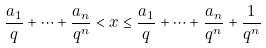<formula> <loc_0><loc_0><loc_500><loc_500>\frac { a _ { 1 } } { q } + \cdots + \frac { a _ { n } } { q ^ { n } } < x \leq \frac { a _ { 1 } } { q } + \cdots + \frac { a _ { n } } { q ^ { n } } + \frac { 1 } { q ^ { n } }</formula> 